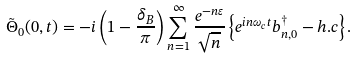Convert formula to latex. <formula><loc_0><loc_0><loc_500><loc_500>\tilde { \Theta } _ { 0 } ( 0 , t ) = { - i } \left ( 1 - \frac { \delta _ { B } } { \pi } \right ) \sum _ { n = 1 } ^ { \infty } \frac { e ^ { - n \varepsilon } } { \sqrt { n } } \left \{ e ^ { i n \omega _ { c } t } b _ { n , 0 } ^ { \dagger } - h . c \right \} .</formula> 